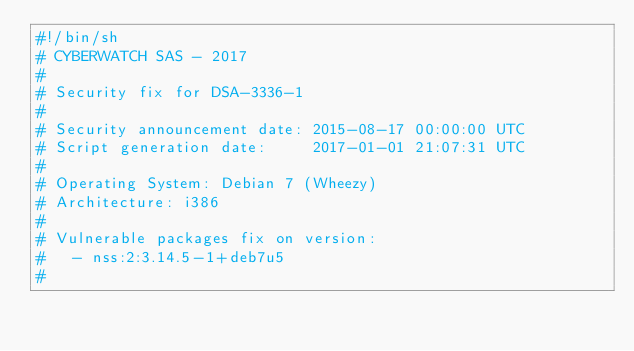Convert code to text. <code><loc_0><loc_0><loc_500><loc_500><_Bash_>#!/bin/sh
# CYBERWATCH SAS - 2017
#
# Security fix for DSA-3336-1
#
# Security announcement date: 2015-08-17 00:00:00 UTC
# Script generation date:     2017-01-01 21:07:31 UTC
#
# Operating System: Debian 7 (Wheezy)
# Architecture: i386
#
# Vulnerable packages fix on version:
#   - nss:2:3.14.5-1+deb7u5
#</code> 